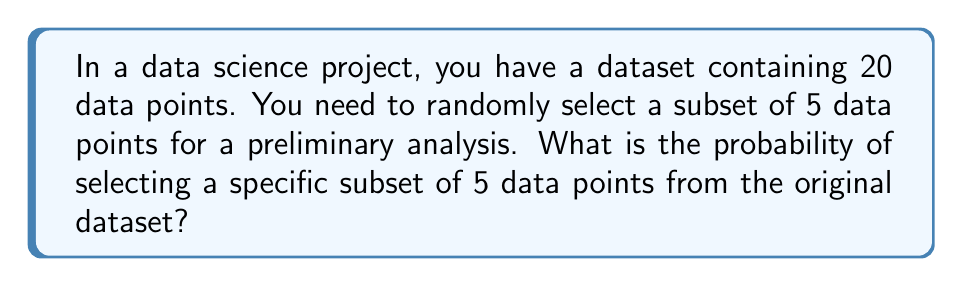Help me with this question. Let's approach this step-by-step:

1) This problem is a combination problem. We're selecting 5 items from a set of 20, where the order doesn't matter.

2) The total number of possible ways to select 5 items from 20 is given by the combination formula:

   $$\binom{20}{5} = \frac{20!}{5!(20-5)!} = \frac{20!}{5!15!}$$

3) Let's calculate this:
   
   $$\binom{20}{5} = \frac{20 * 19 * 18 * 17 * 16}{5 * 4 * 3 * 2 * 1} = 15,504$$

4) Now, the probability of selecting any specific subset of 5 is:

   $$P(\text{specific subset}) = \frac{1}{\text{total number of possible subsets}}$$

5) Therefore:

   $$P(\text{specific subset}) = \frac{1}{15,504}$$

6) To express this as a decimal, we divide 1 by 15,504:

   $$P(\text{specific subset}) \approx 0.0000645$$

So, the probability is approximately 0.0000645 or about 0.00645%.
Answer: $\frac{1}{15,504}$ or approximately 0.0000645 